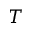Convert formula to latex. <formula><loc_0><loc_0><loc_500><loc_500>T</formula> 